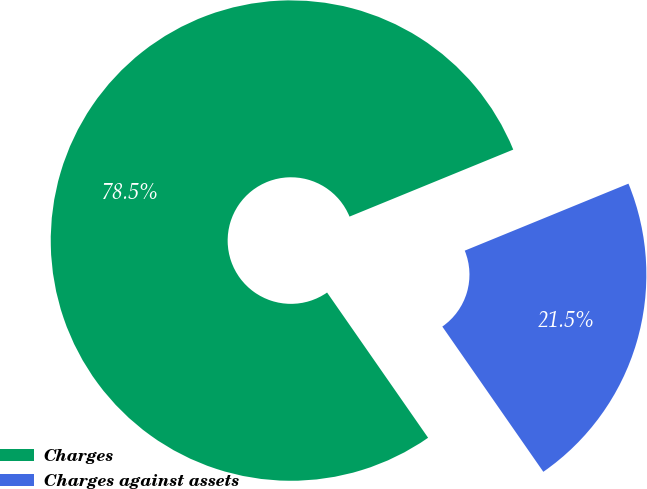Convert chart to OTSL. <chart><loc_0><loc_0><loc_500><loc_500><pie_chart><fcel>Charges<fcel>Charges against assets<nl><fcel>78.49%<fcel>21.51%<nl></chart> 